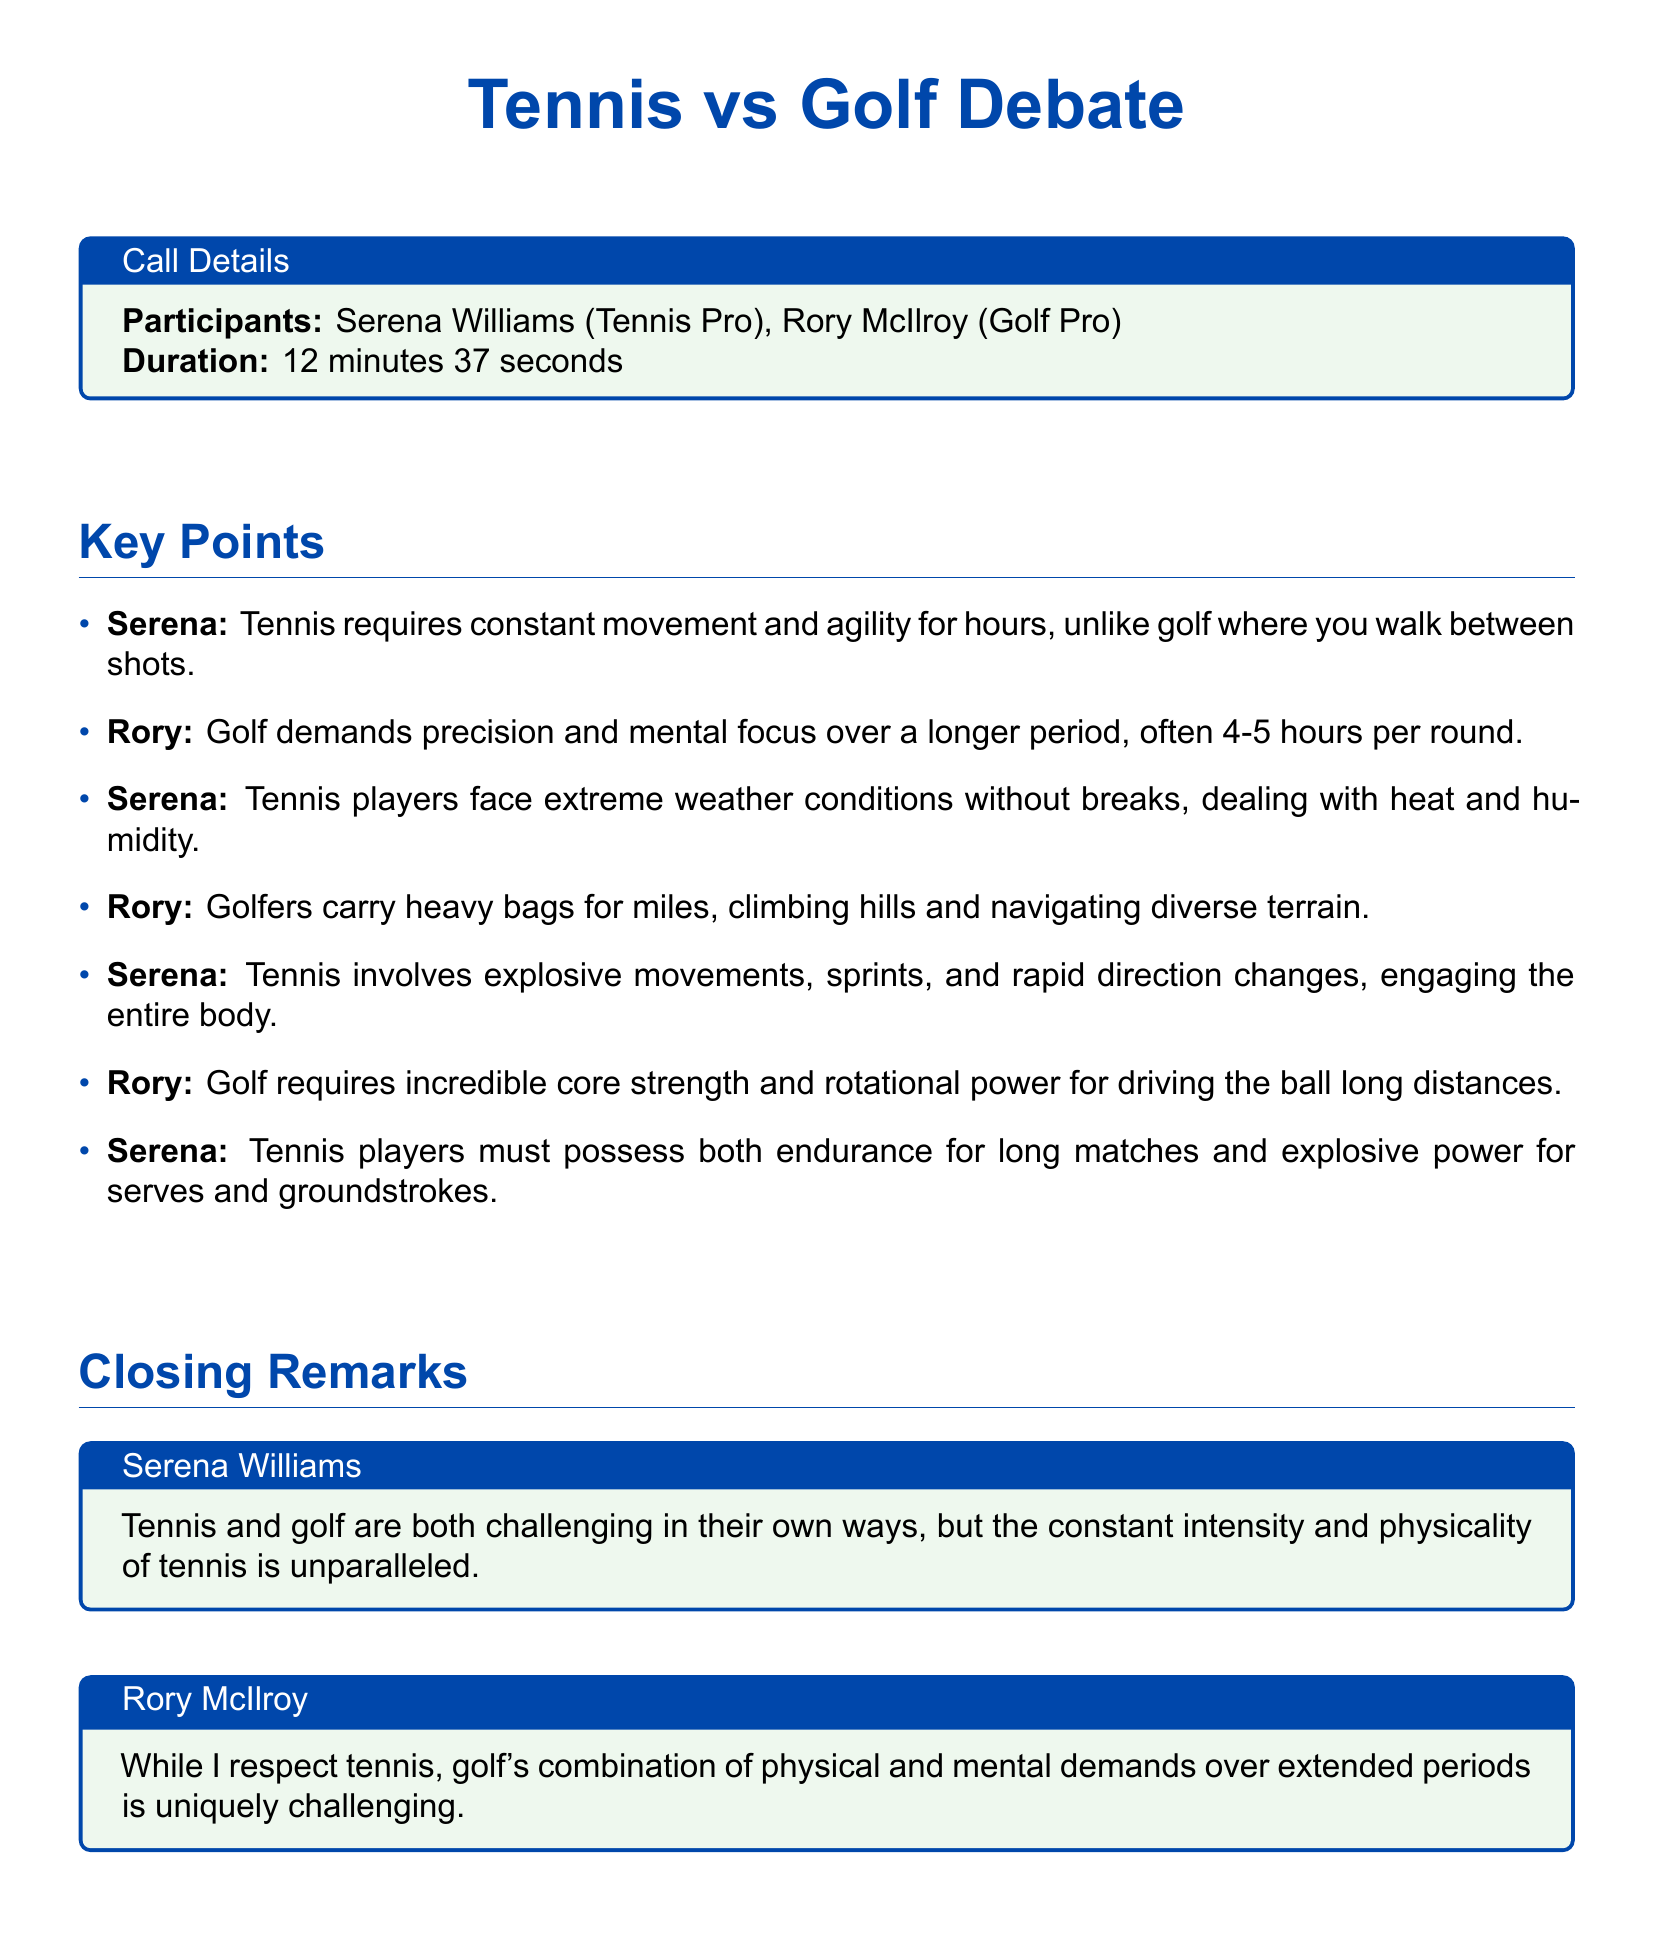What is the duration of the debate? The duration of the debate is mentioned in the call details section of the document.
Answer: 12 minutes 37 seconds Who are the participants in the debate? The participants are listed in the call details section.
Answer: Serena Williams, Rory McIlroy What sport does Rory McIlroy play? Rory McIlroy's profession is specified in the document under participants.
Answer: Golf What type of movements does Serena attribute to tennis players? Serena's statement includes a focus on the physical aspects of tennis compared to golf.
Answer: Explosive movements How long can a round of golf take according to Rory? Rory mentions the duration of a golf round in his argument.
Answer: 4-5 hours What is one of Serena's closing remarks about tennis? Serena's closing remarks encapsulate her view on the physicality of tennis.
Answer: Unparalleled What environmental conditions do tennis players deal with? Serena discusses the conditions faced by tennis players during matches.
Answer: Heat and humidity Which sport requires core strength and rotational power according to Rory? Rory describes the physical demands of golf specifically in terms of body strength.
Answer: Golf What is the color theme used in the document? The document features colors specified for headers and boxes.
Answer: Tennis blue and tennis green 